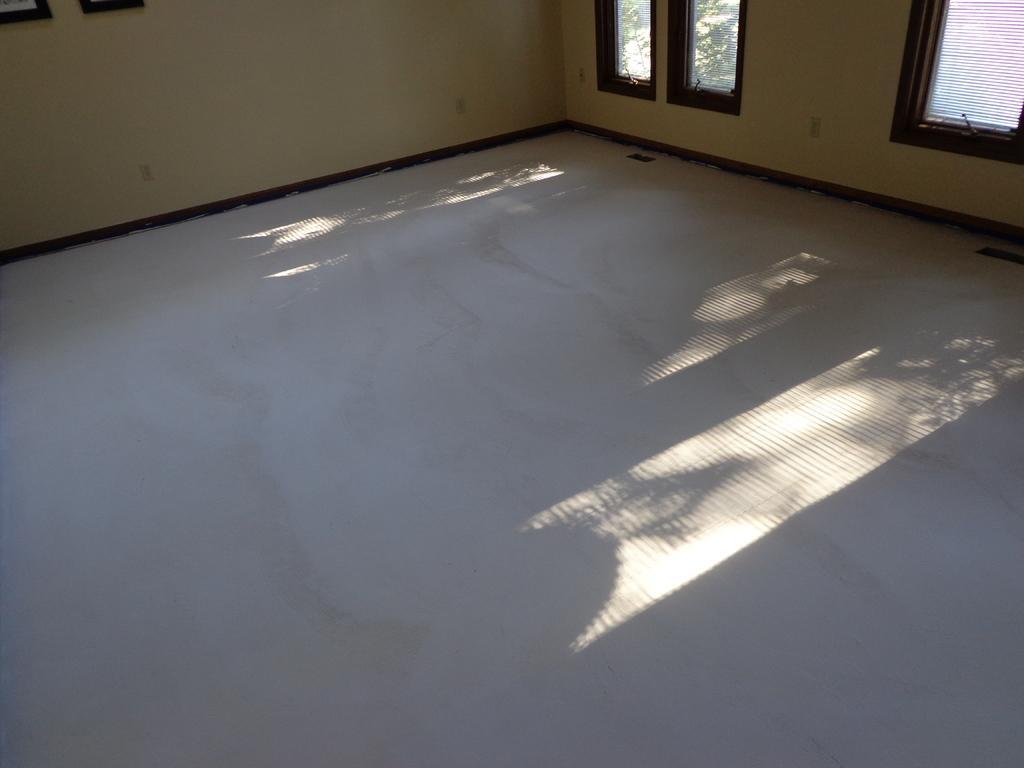In one or two sentences, can you explain what this image depicts? In the center of the image there is a floor, wall, photo frames and windows. Through window glass, we can see trees. 